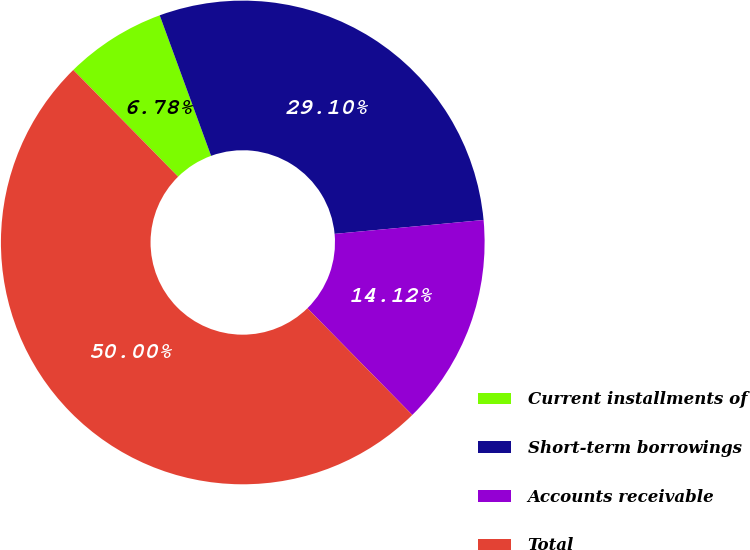<chart> <loc_0><loc_0><loc_500><loc_500><pie_chart><fcel>Current installments of<fcel>Short-term borrowings<fcel>Accounts receivable<fcel>Total<nl><fcel>6.78%<fcel>29.1%<fcel>14.12%<fcel>50.0%<nl></chart> 